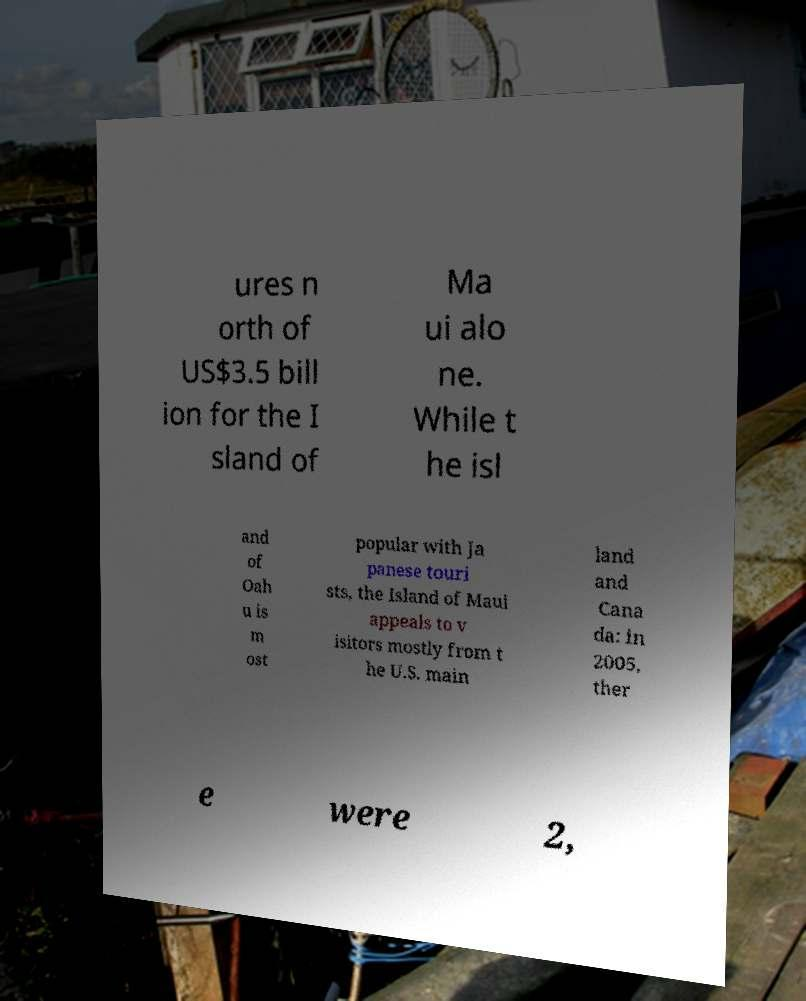For documentation purposes, I need the text within this image transcribed. Could you provide that? ures n orth of US$3.5 bill ion for the I sland of Ma ui alo ne. While t he isl and of Oah u is m ost popular with Ja panese touri sts, the Island of Maui appeals to v isitors mostly from t he U.S. main land and Cana da: in 2005, ther e were 2, 